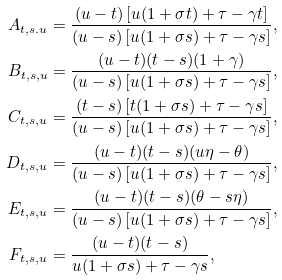<formula> <loc_0><loc_0><loc_500><loc_500>A _ { t , s . u } & = \frac { ( u - t ) \left [ u ( 1 + \sigma t ) + \tau - \gamma t \right ] } { ( u - s ) \left [ u ( 1 + \sigma s ) + \tau - \gamma s \right ] } , \\ B _ { t , s , u } & = \frac { ( u - t ) ( t - s ) ( 1 + \gamma ) } { ( u - s ) \left [ u ( 1 + \sigma s ) + \tau - \gamma s \right ] } , \\ C _ { t , s , u } & = \frac { ( t - s ) \left [ t ( 1 + \sigma s ) + \tau - \gamma s \right ] } { ( u - s ) \left [ u ( 1 + \sigma s ) + \tau - \gamma s \right ] } , \\ D _ { t , s , u } & = \frac { ( u - t ) ( t - s ) ( u \eta - \theta ) } { ( u - s ) \left [ u ( 1 + \sigma s ) + \tau - \gamma s \right ] } , \\ E _ { t , s , u } & = \frac { ( u - t ) ( t - s ) ( \theta - s \eta ) } { ( u - s ) \left [ u ( 1 + \sigma s ) + \tau - \gamma s \right ] } , \\ F _ { t , s , u } & = \frac { ( u - t ) ( t - s ) } { u ( 1 + \sigma s ) + \tau - \gamma s } ,</formula> 